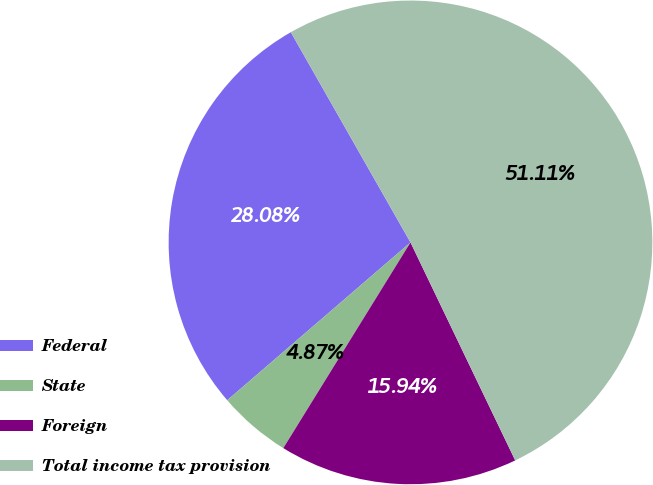<chart> <loc_0><loc_0><loc_500><loc_500><pie_chart><fcel>Federal<fcel>State<fcel>Foreign<fcel>Total income tax provision<nl><fcel>28.08%<fcel>4.87%<fcel>15.94%<fcel>51.11%<nl></chart> 